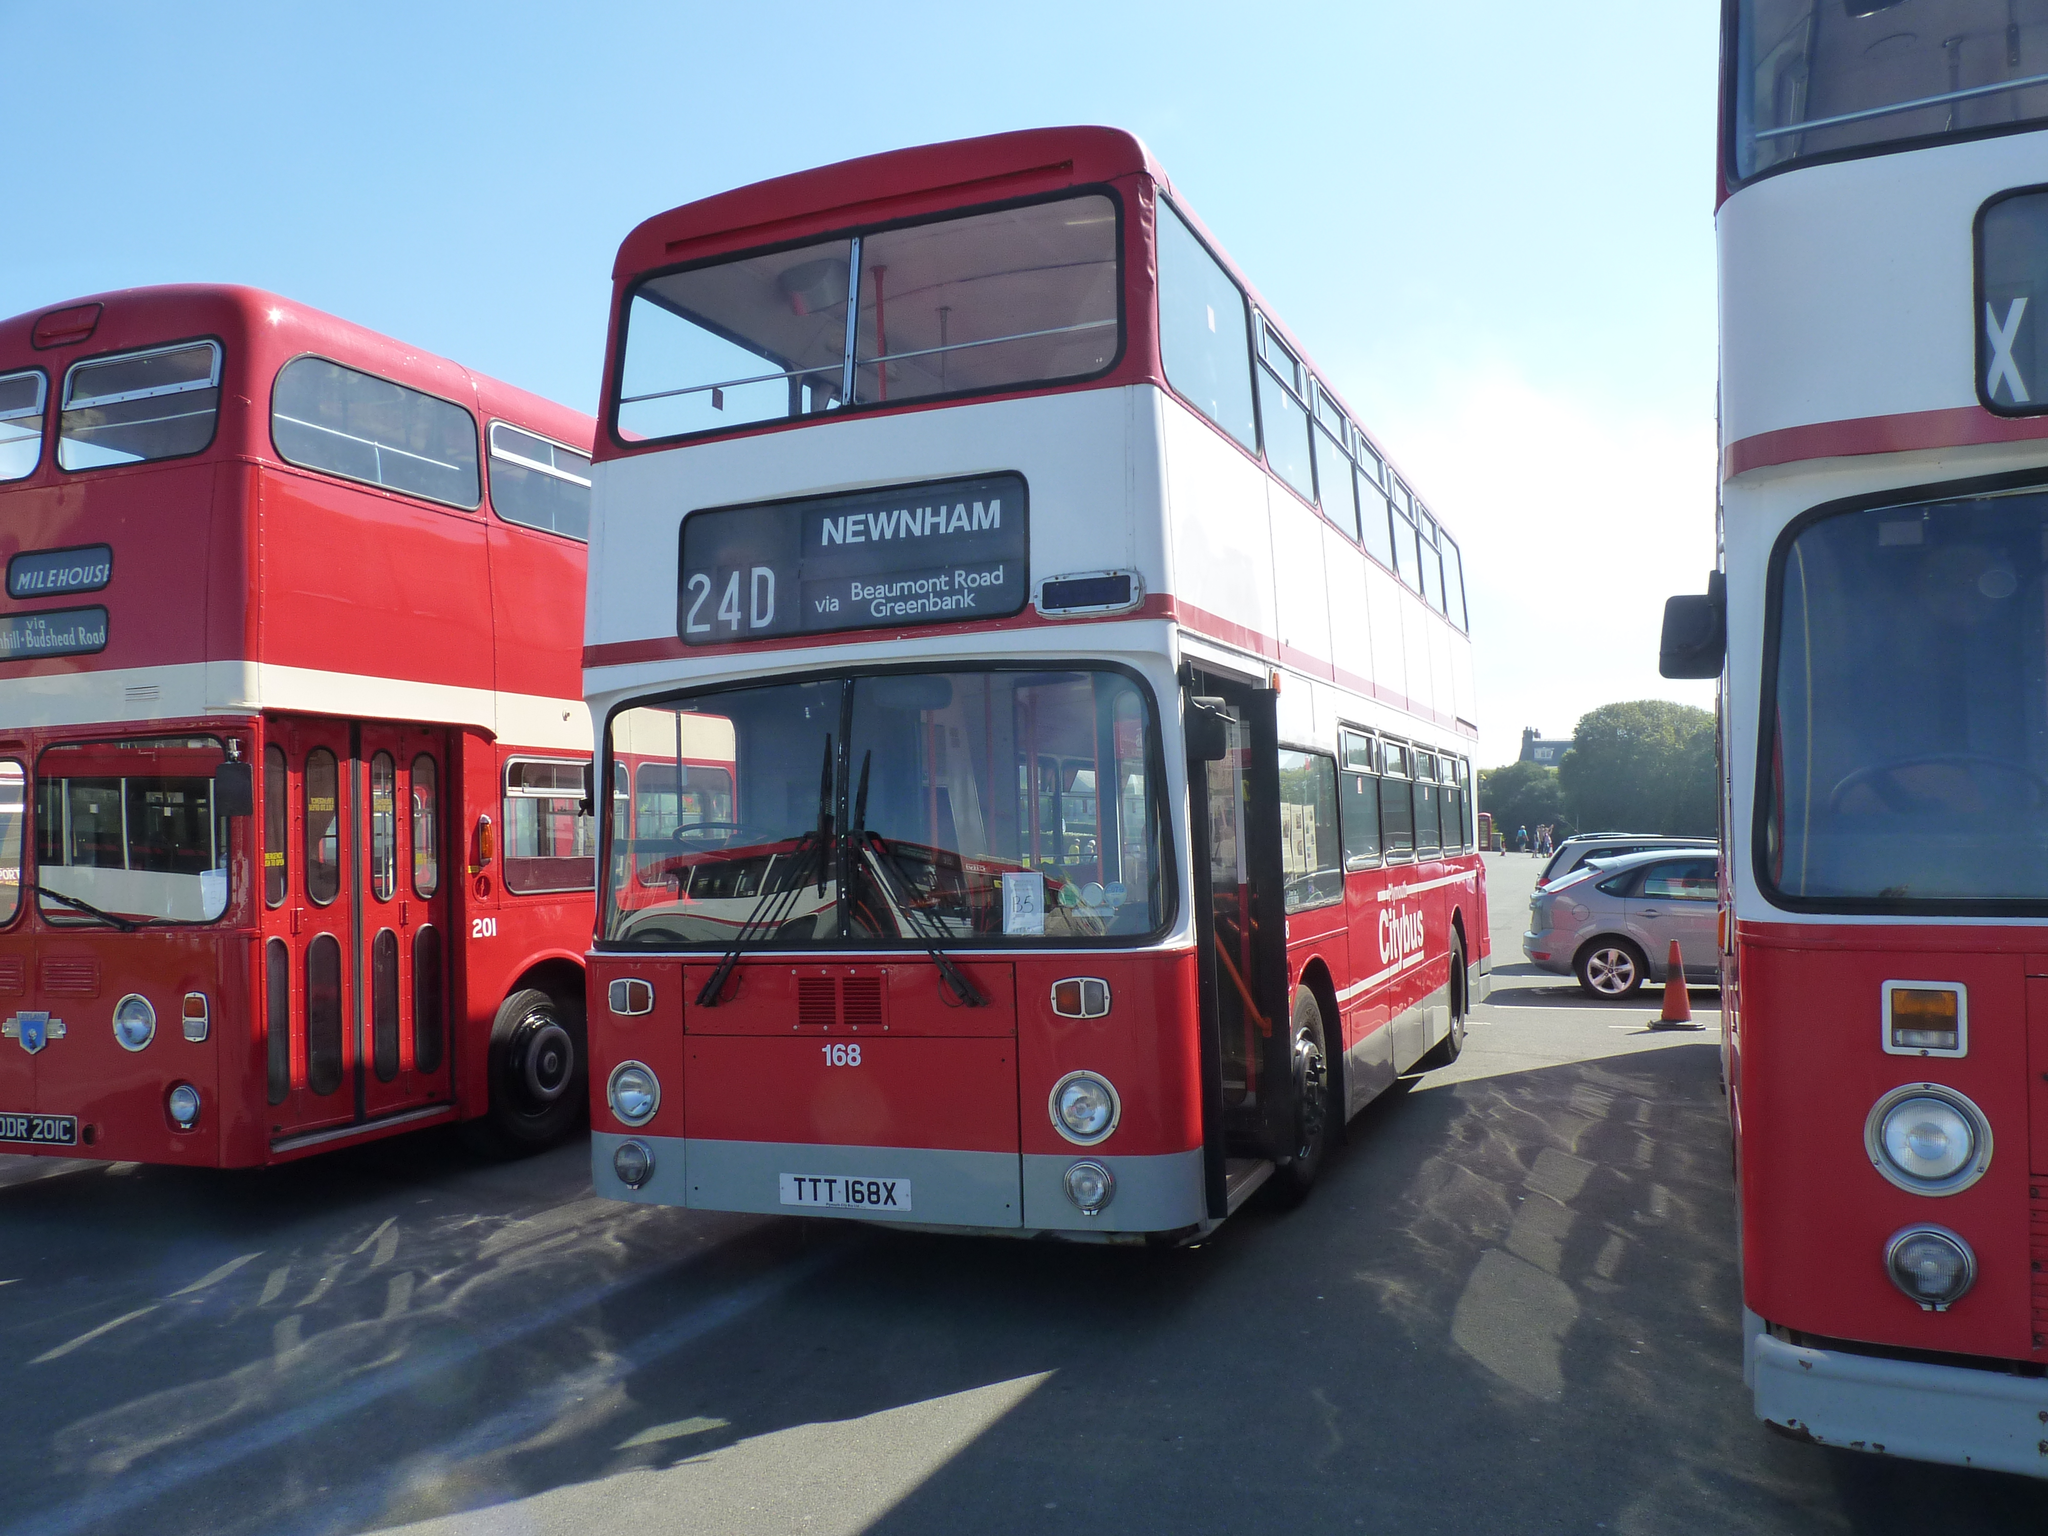<image>
Summarize the visual content of the image. Three double decker buses that say Newnham are parked in a lot. 